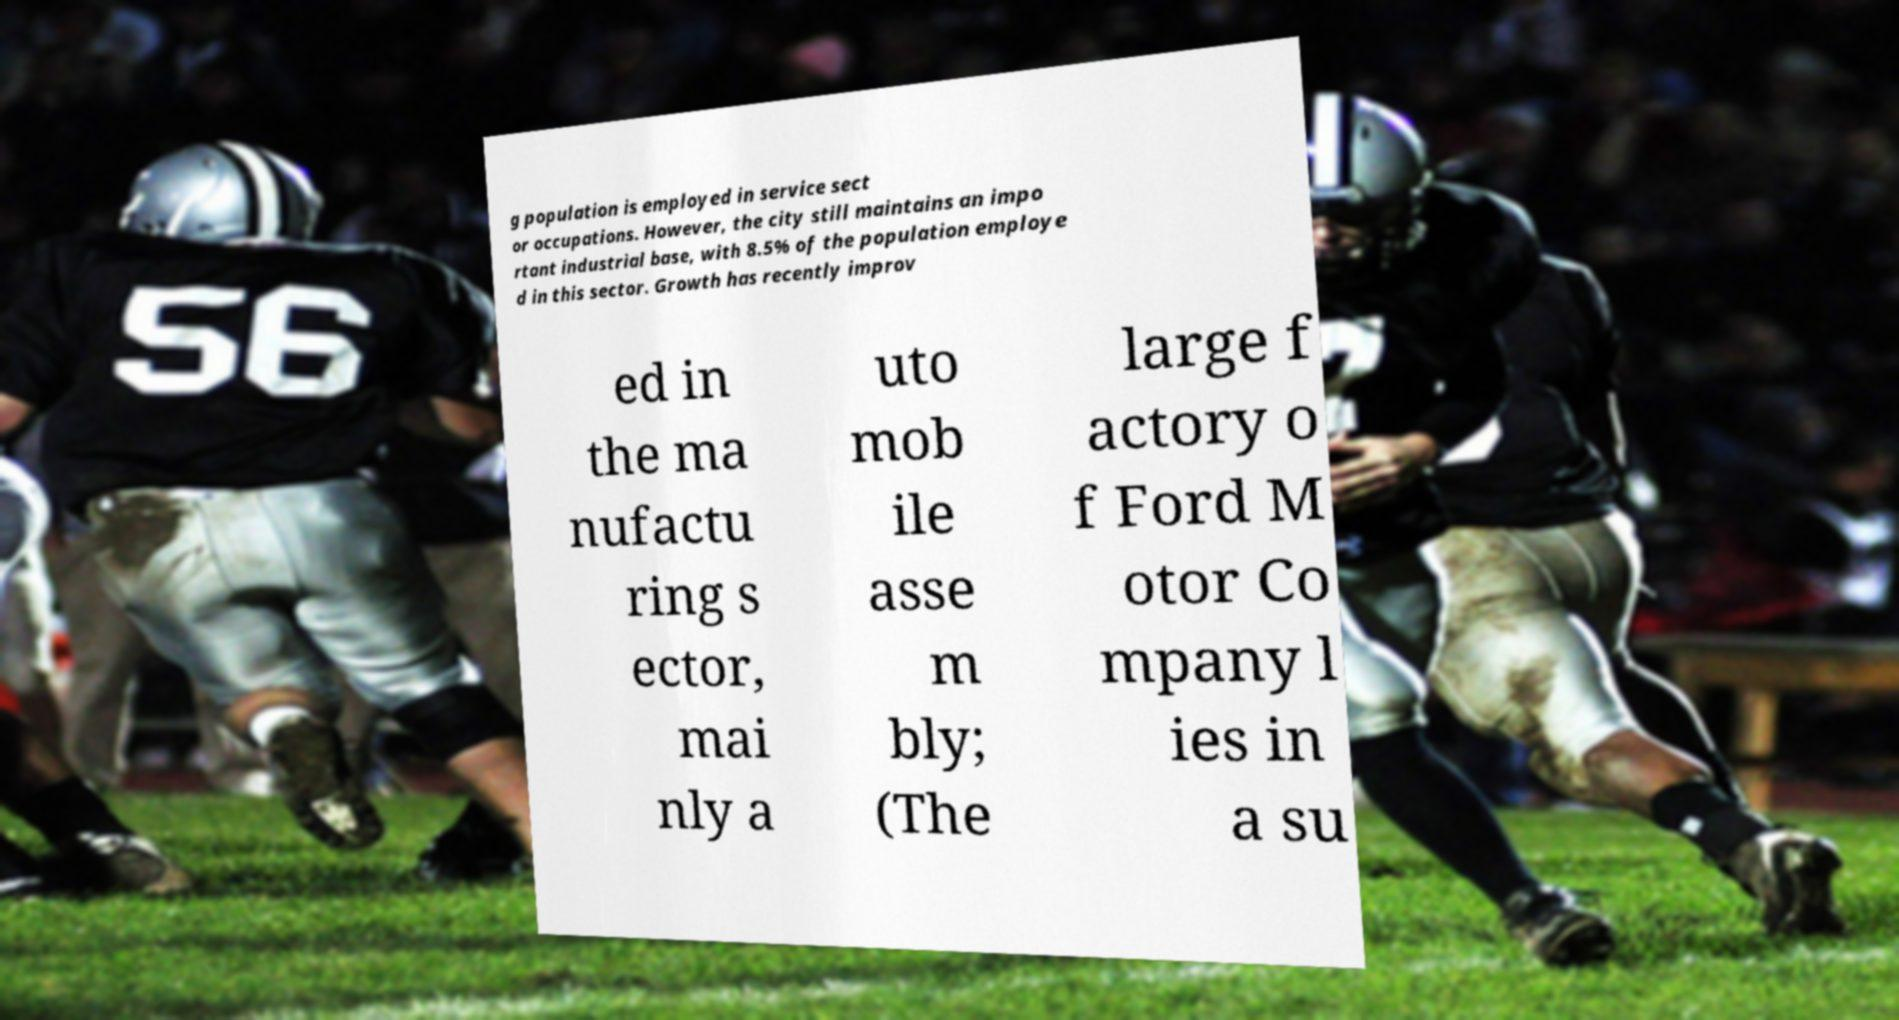Can you accurately transcribe the text from the provided image for me? g population is employed in service sect or occupations. However, the city still maintains an impo rtant industrial base, with 8.5% of the population employe d in this sector. Growth has recently improv ed in the ma nufactu ring s ector, mai nly a uto mob ile asse m bly; (The large f actory o f Ford M otor Co mpany l ies in a su 